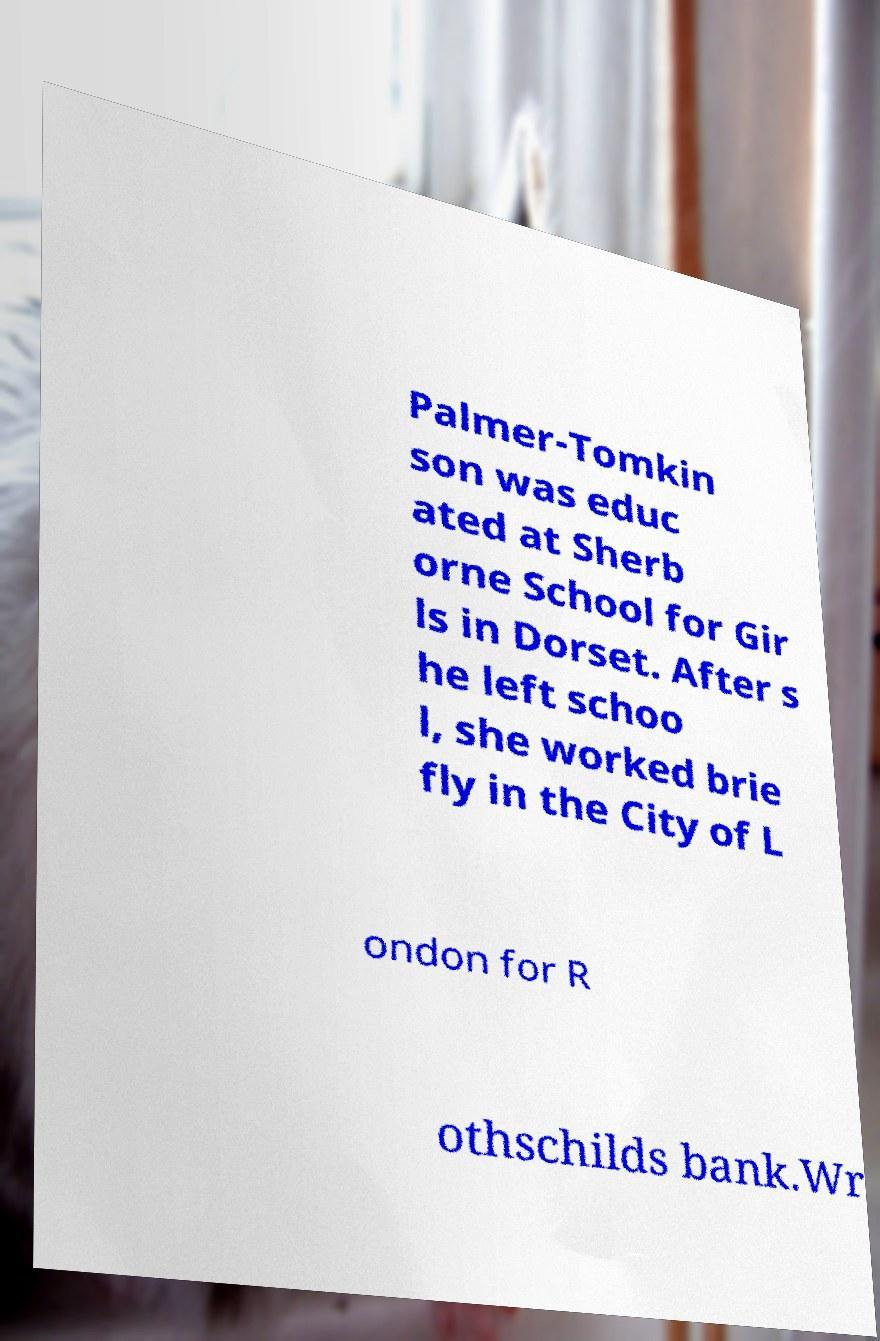Can you accurately transcribe the text from the provided image for me? Palmer-Tomkin son was educ ated at Sherb orne School for Gir ls in Dorset. After s he left schoo l, she worked brie fly in the City of L ondon for R othschilds bank.Wr 